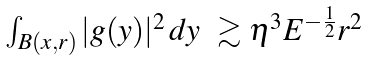Convert formula to latex. <formula><loc_0><loc_0><loc_500><loc_500>\begin{array} { l l } \int _ { B ( x , r ) } | g ( y ) | ^ { 2 } \, d y & \gtrsim \eta ^ { 3 } E ^ { - \frac { 1 } { 2 } } r ^ { 2 } \end{array}</formula> 